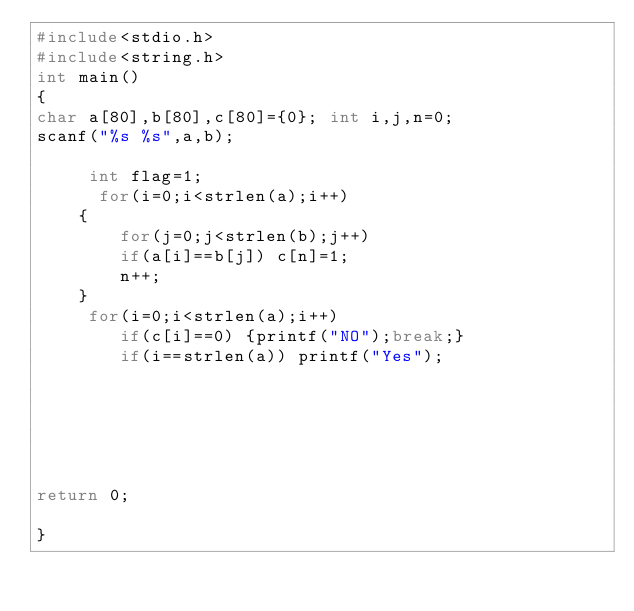Convert code to text. <code><loc_0><loc_0><loc_500><loc_500><_C++_>#include<stdio.h>
#include<string.h>
int main()
{
char a[80],b[80],c[80]={0}; int i,j,n=0;
scanf("%s %s",a,b);
	
	 int flag=1;
	  for(i=0;i<strlen(a);i++)
	{
	    for(j=0;j<strlen(b);j++)
	    if(a[i]==b[j]) c[n]=1;
     	n++;
	}
	 for(i=0;i<strlen(a);i++)
     	if(c[i]==0) {printf("NO");break;}
	    if(i==strlen(a)) printf("Yes");
	
	
	
	


return 0;

}</code> 